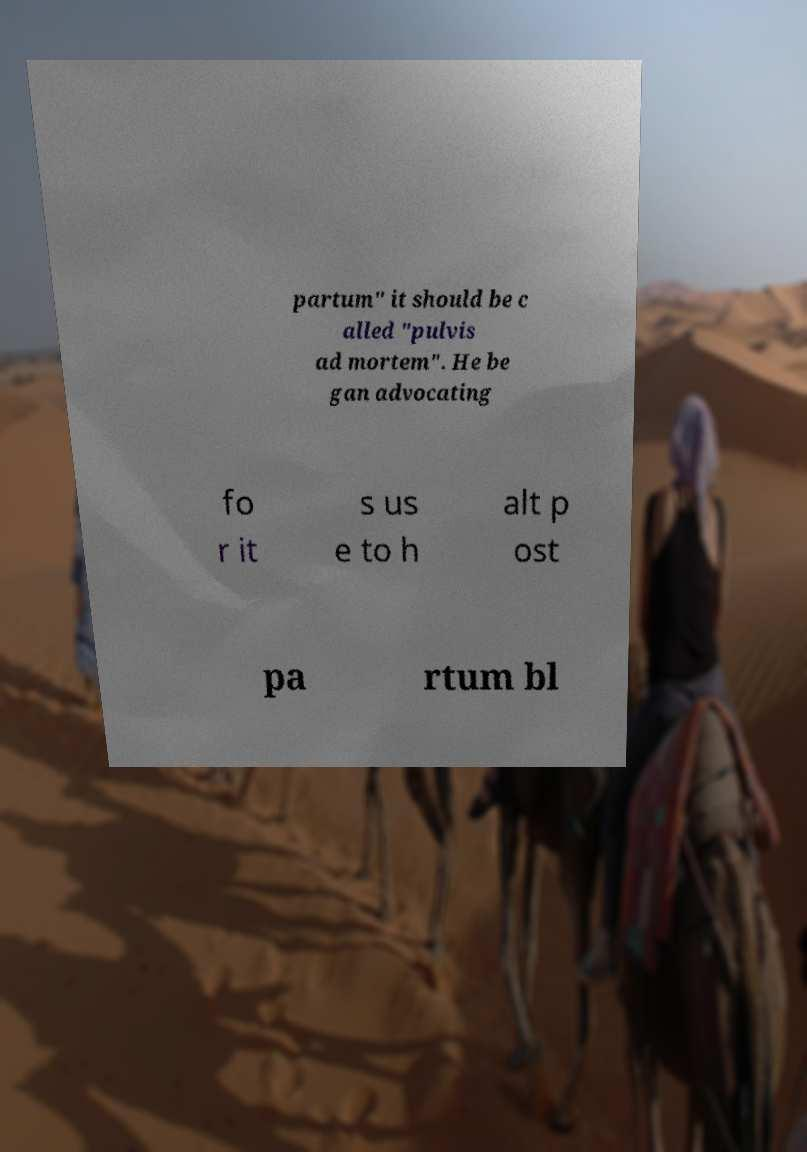Can you read and provide the text displayed in the image?This photo seems to have some interesting text. Can you extract and type it out for me? partum" it should be c alled "pulvis ad mortem". He be gan advocating fo r it s us e to h alt p ost pa rtum bl 